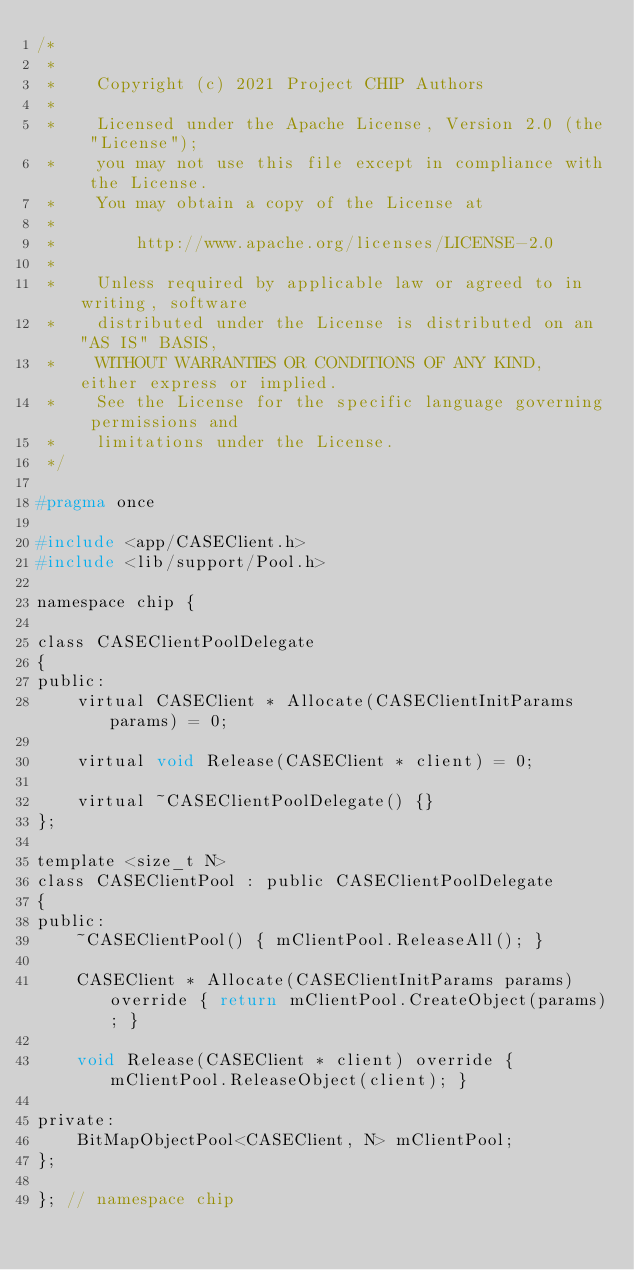Convert code to text. <code><loc_0><loc_0><loc_500><loc_500><_C_>/*
 *
 *    Copyright (c) 2021 Project CHIP Authors
 *
 *    Licensed under the Apache License, Version 2.0 (the "License");
 *    you may not use this file except in compliance with the License.
 *    You may obtain a copy of the License at
 *
 *        http://www.apache.org/licenses/LICENSE-2.0
 *
 *    Unless required by applicable law or agreed to in writing, software
 *    distributed under the License is distributed on an "AS IS" BASIS,
 *    WITHOUT WARRANTIES OR CONDITIONS OF ANY KIND, either express or implied.
 *    See the License for the specific language governing permissions and
 *    limitations under the License.
 */

#pragma once

#include <app/CASEClient.h>
#include <lib/support/Pool.h>

namespace chip {

class CASEClientPoolDelegate
{
public:
    virtual CASEClient * Allocate(CASEClientInitParams params) = 0;

    virtual void Release(CASEClient * client) = 0;

    virtual ~CASEClientPoolDelegate() {}
};

template <size_t N>
class CASEClientPool : public CASEClientPoolDelegate
{
public:
    ~CASEClientPool() { mClientPool.ReleaseAll(); }

    CASEClient * Allocate(CASEClientInitParams params) override { return mClientPool.CreateObject(params); }

    void Release(CASEClient * client) override { mClientPool.ReleaseObject(client); }

private:
    BitMapObjectPool<CASEClient, N> mClientPool;
};

}; // namespace chip
</code> 